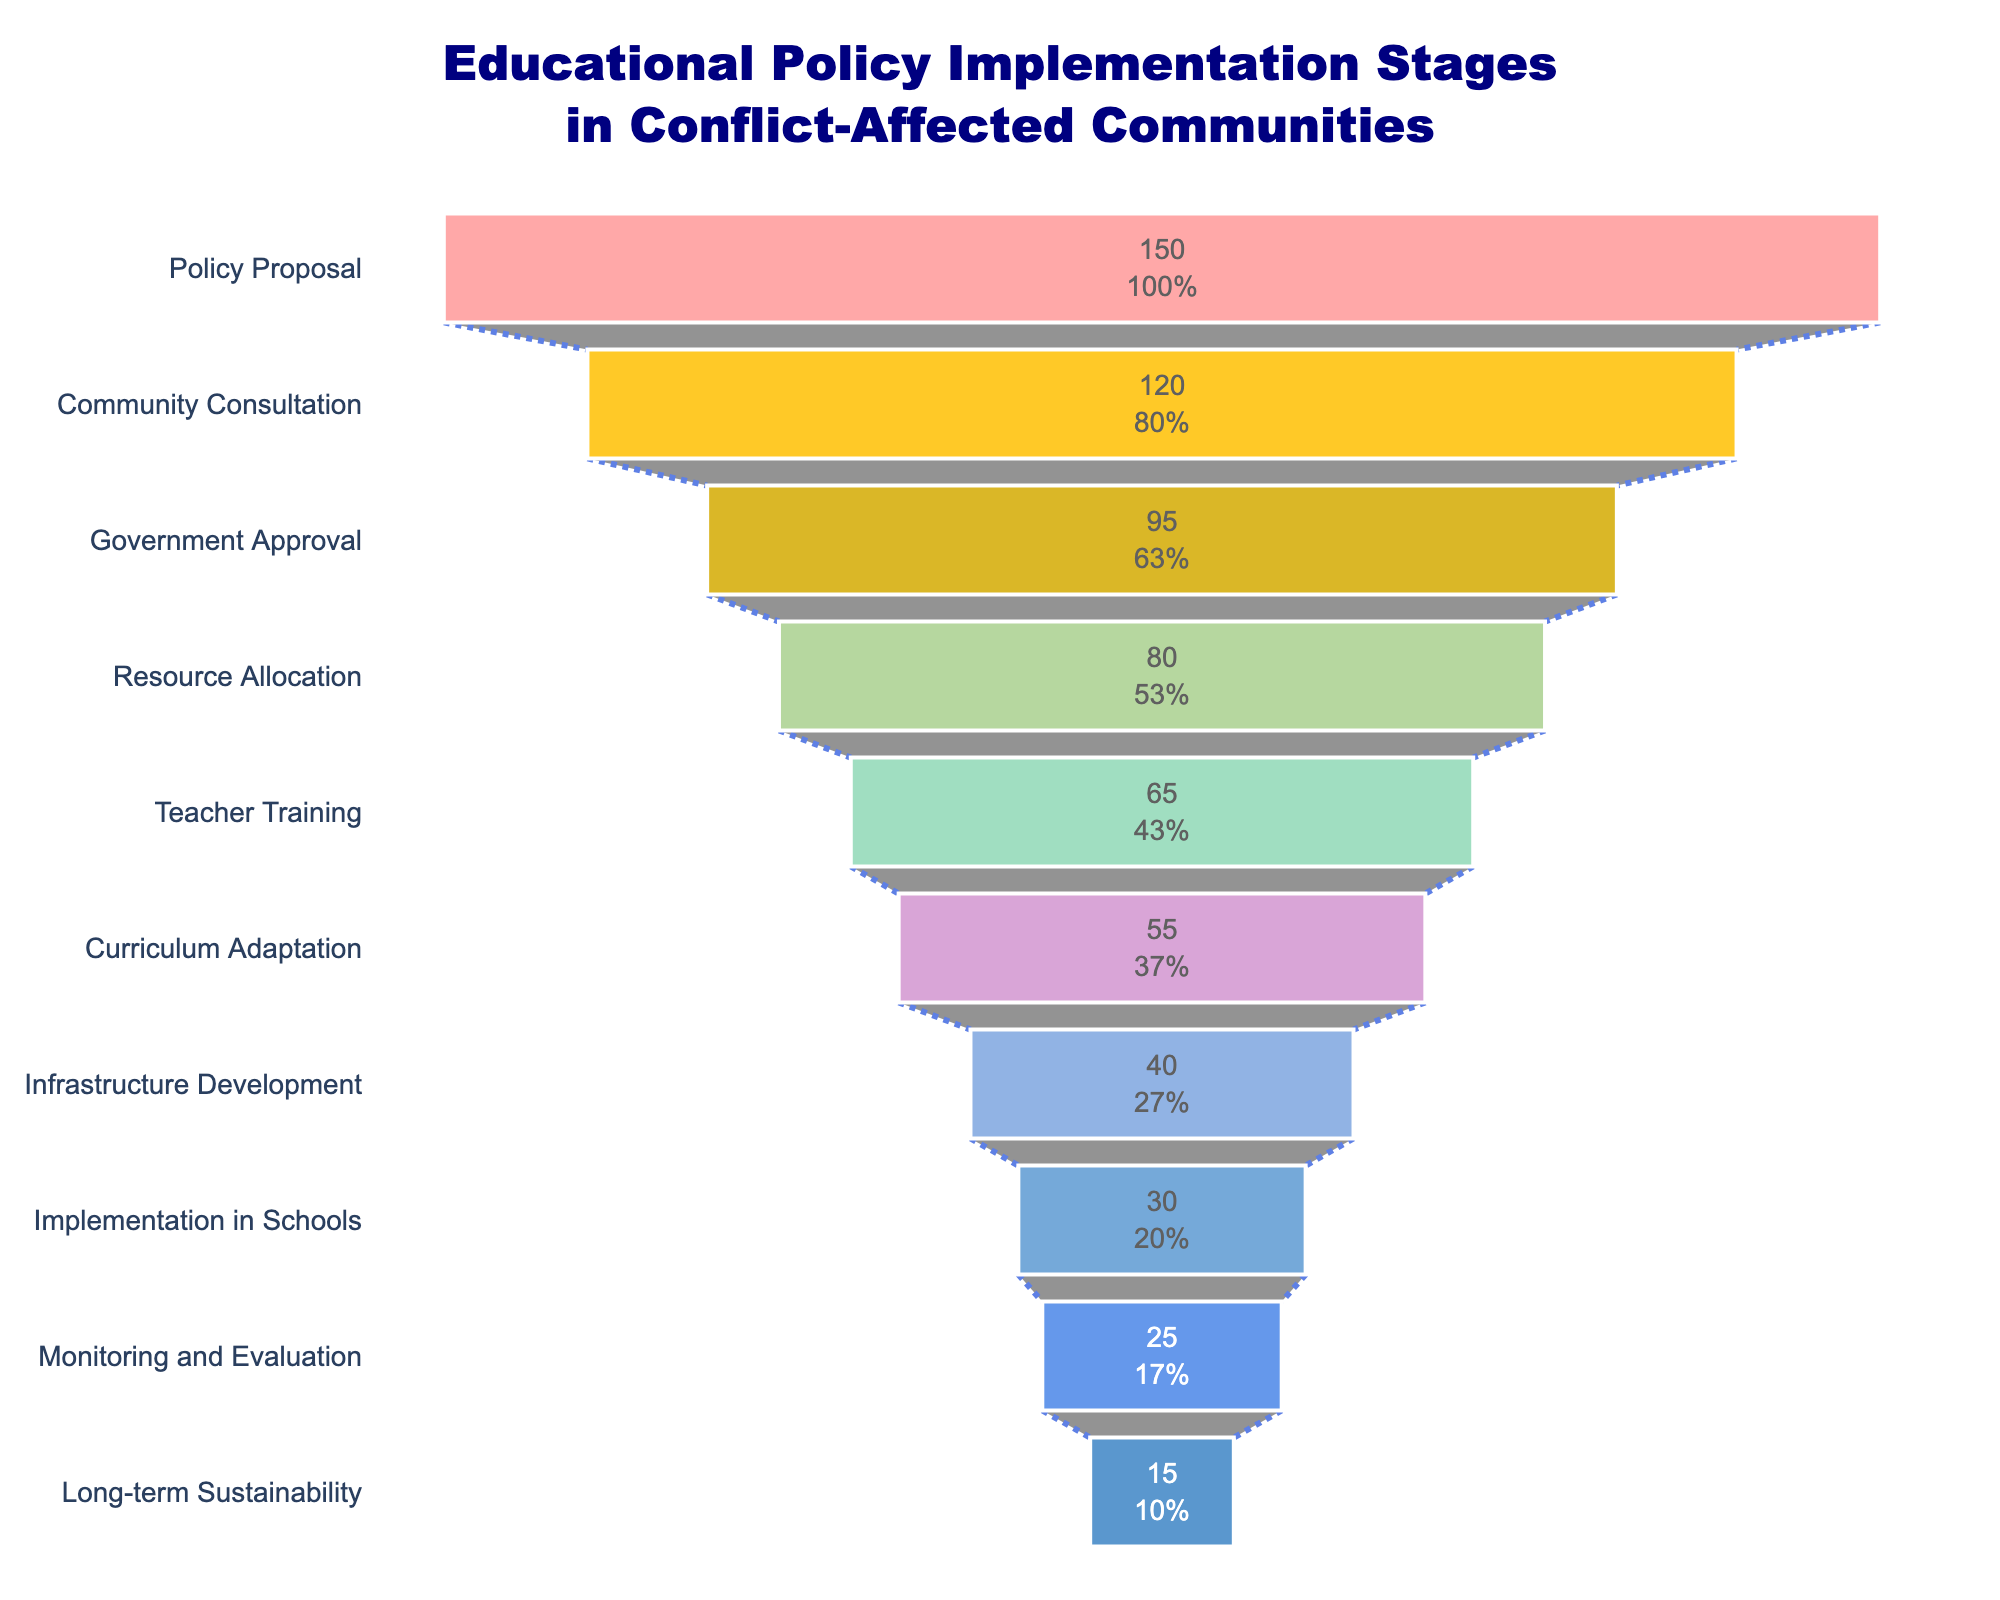What's the title of the chart? The title of the chart is displayed at the top of the funnel chart. It reads "Educational Policy Implementation Stages in Conflict-Affected Communities," which describes what the chart represents.
Answer: "Educational Policy Implementation Stages in Conflict-Affected Communities" What is the first stage in the policy implementation process? The first stage in the funnel chart is located at the top and is labeled "Policy Proposal," indicating the starting point of the policy implementation process.
Answer: Policy Proposal Which stage has the highest number of policies? The stage with the highest number of policies is shown at the widest part of the funnel. It is the "Policy Proposal" stage with 150 policies.
Answer: Policy Proposal What percentage of policies reach the "Implementation in Schools" stage compared to the initial "Policy Proposal" stage? The "Implementation in Schools" stage has 30 policies, and the "Policy Proposal" stage has 150 policies. The percentage can be calculated as (30/150) * 100, which equals 20%.
Answer: 20% How many policies are lost between the "Government Approval" and "Resource Allocation" stages? The number of policies at the "Government Approval" stage is 95, and at the "Resource Allocation" stage, it is 80. The number of policies lost can be calculated as 95 - 80, which equals 15 policies.
Answer: 15 By how much does the number of policies decrease from the "Teacher Training" to the "Monitoring and Evaluation" stage? The "Teacher Training" stage has 65 policies, and the "Monitoring and Evaluation" stage has 25 policies. The decrease can be calculated as 65 - 25, which is 40 policies.
Answer: 40 Which stage has the lowest number of policies? The stage with the lowest number of policies is at the bottom of the funnel chart, which is the "Long-term Sustainability" stage with 15 policies.
Answer: Long-term Sustainability What is the difference between the number of policies at the "Community Consultation" and "Curriculum Adaptation" stages? The "Community Consultation" stage has 120 policies and the "Curriculum Adaptation" stage has 55 policies. The difference is 120 - 55, which equals 65 policies.
Answer: 65 Which stages have fewer than 50 policies? By looking at the middle to lower parts of the funnel chart, the stages with fewer than 50 policies are "Infrastructure Development" (40 policies), "Implementation in Schools" (30 policies), "Monitoring and Evaluation" (25 policies), and "Long-term Sustainability" (15 policies).
Answer: Four stages: Infrastructure Development, Implementation in Schools, Monitoring and Evaluation, Long-term Sustainability 